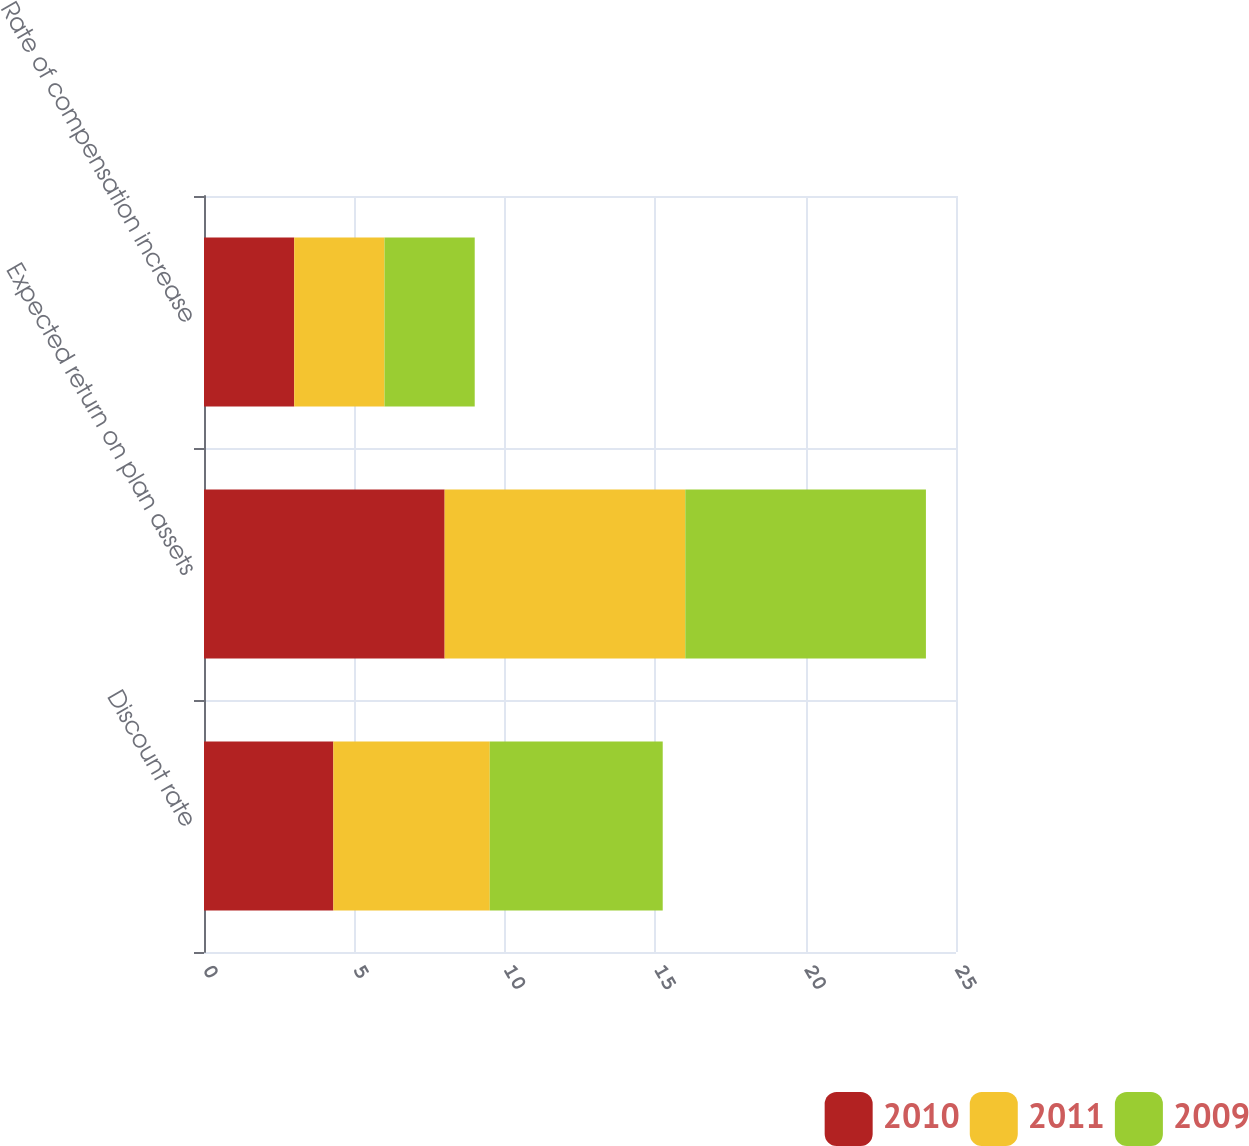<chart> <loc_0><loc_0><loc_500><loc_500><stacked_bar_chart><ecel><fcel>Discount rate<fcel>Expected return on plan assets<fcel>Rate of compensation increase<nl><fcel>2010<fcel>4.3<fcel>8<fcel>3<nl><fcel>2011<fcel>5.2<fcel>8<fcel>3<nl><fcel>2009<fcel>5.75<fcel>8<fcel>3<nl></chart> 